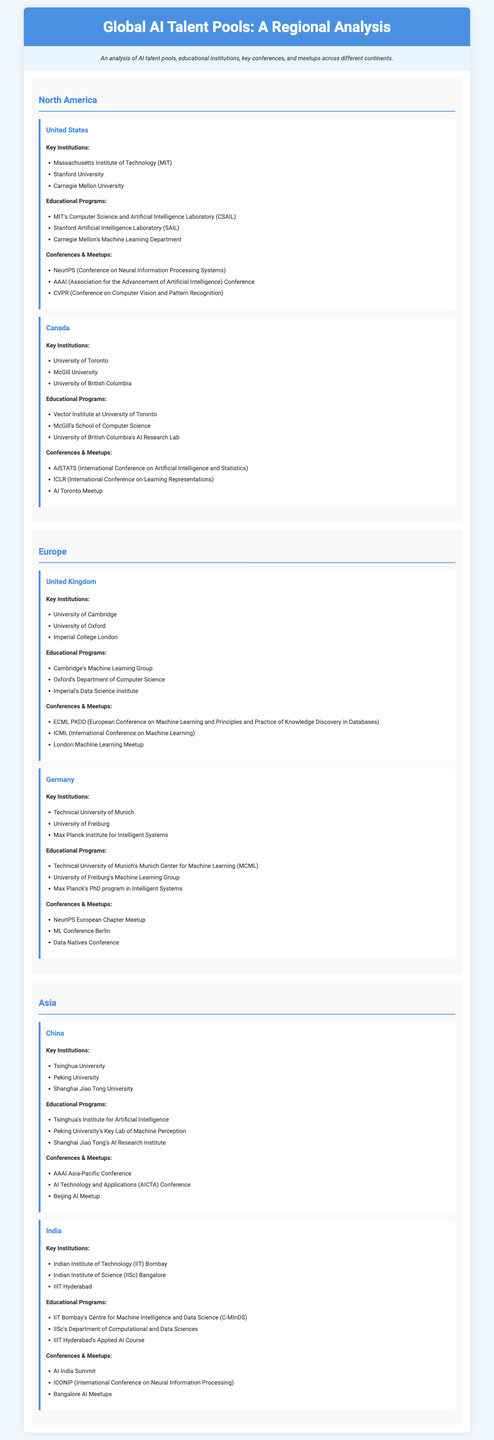What are the key institutions in the United States? The key institutions in the United States include Massachusetts Institute of Technology (MIT), Stanford University, and Carnegie Mellon University.
Answer: Massachusetts Institute of Technology (MIT), Stanford University, Carnegie Mellon University Which Canadian university is associated with the Vector Institute? The Vector Institute is associated with the University of Toronto.
Answer: University of Toronto How many key institutions are listed for Germany? The document lists three key institutions for Germany: Technical University of Munich, University of Freiburg, and Max Planck Institute for Intelligent Systems.
Answer: Three What is the name of the educational program at Peking University? The educational program at Peking University is called the Key Lab of Machine Perception.
Answer: Key Lab of Machine Perception Which conference is mentioned for both North America and Europe? The conference mentioned for both North America and Europe is NeurIPS, specifically the Conference on Neural Information Processing Systems.
Answer: NeurIPS What educational program does IIT Bombay offer? IIT Bombay offers the Centre for Machine Intelligence and Data Science (C-MInDS).
Answer: Centre for Machine Intelligence and Data Science (C-MInDS) Which Asian country's institutions are mentioned first in the document? The institutions in China are mentioned first in the document.
Answer: China What primary focus can you infer about the institutions listed? The institutions listed primarily focus on artificial intelligence and related fields within computer science.
Answer: Artificial intelligence 